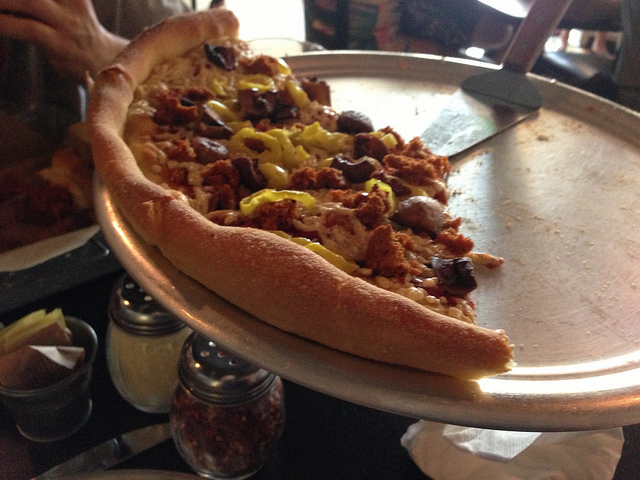<image>What condiments are there? I don't know what condiments are there. It can be pepper and cheese, salt, grated cheese and pepper flakes, or others. What condiments are there? There are various condiments in the image, such as pineapple chicken, black olives, salt, pepper, cheese, grated cheese, pepper flakes, olives, and sausage. 